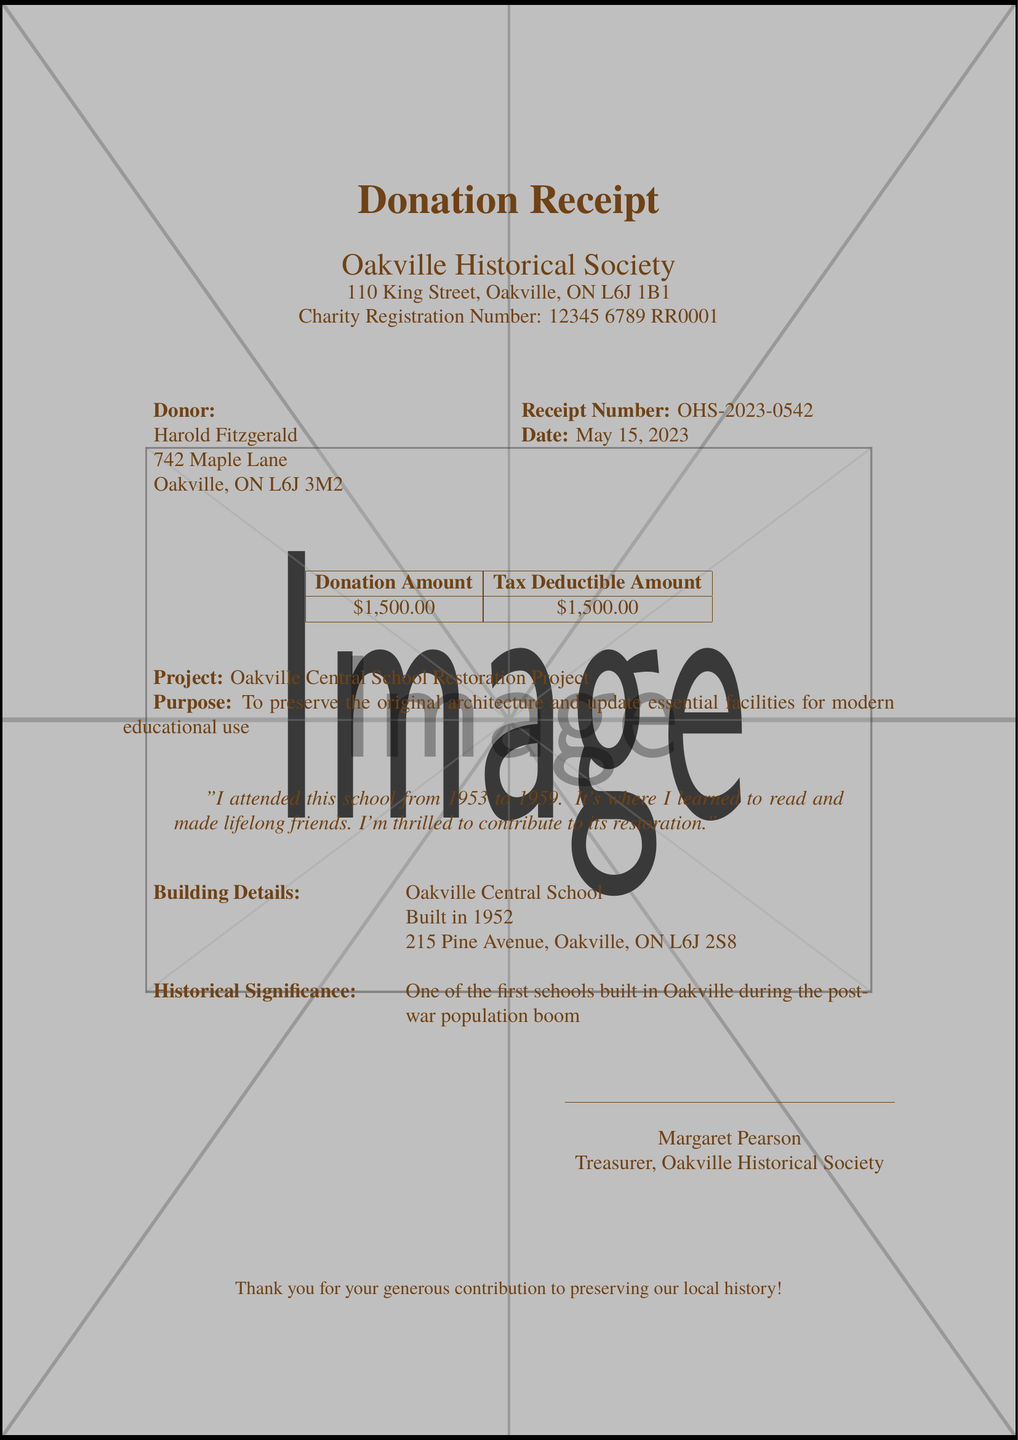What is the donor's name? The donor's name can be found at the top of the receipt document.
Answer: Harold Fitzgerald What is the donation date? The date of donation is specified in the document.
Answer: May 15, 2023 What is the total donation amount? The document lists the donation amount clearly.
Answer: $1,500.00 What is the purpose of the restoration? The purpose is outlined in the document.
Answer: To preserve the original architecture and update essential facilities for modern educational use What is the recipient organization? The organization receiving the donation is mentioned in the header of the document.
Answer: Oakville Historical Society What is the tax receipt number? The document explicitly lists the receipt number related to the donation.
Answer: OHS-2023-0542 How many phases does the restoration project have? The document details the project phases, providing a count.
Answer: 6 What historical significance is stated? The document describes the historical significance of the building.
Answer: One of the first schools built in Oakville during the post-war population boom What is the estimated completion date? The document states the estimated completion date for the project.
Answer: August 31, 2024 